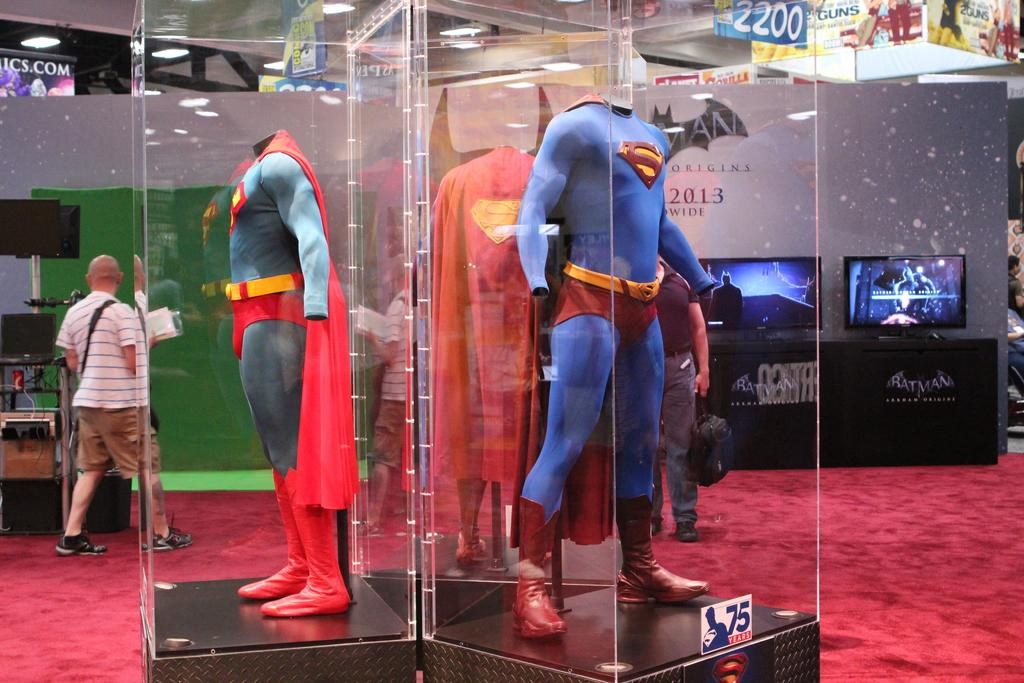<image>
Render a clear and concise summary of the photo. The S on the costume stands for Superman and there are several displays of it. 